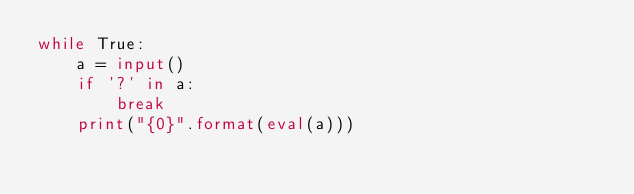Convert code to text. <code><loc_0><loc_0><loc_500><loc_500><_Python_>while True:
    a = input()
    if '?' in a:
        break
    print("{0}".format(eval(a)))</code> 